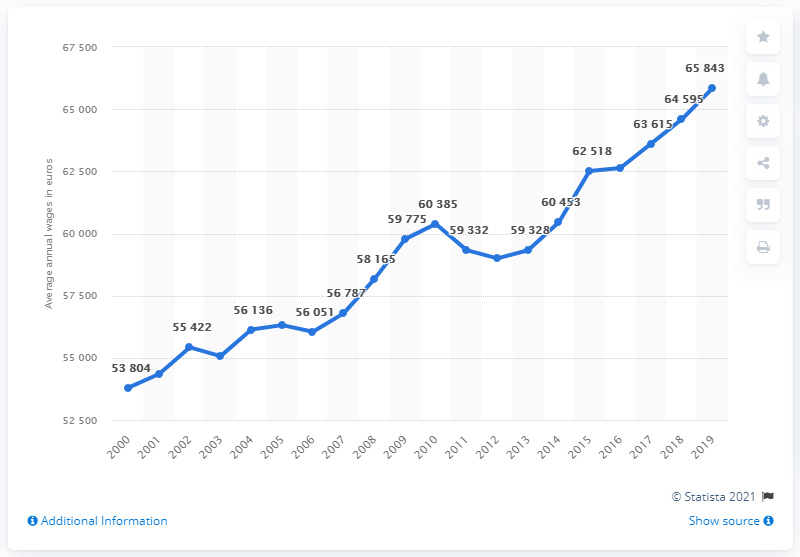List a handful of essential elements in this visual. In 2000, the average annual wage in Luxembourg was approximately 56,787 euros. In 2019, the highest annual wage in Luxembourg was 65,843 euros. 